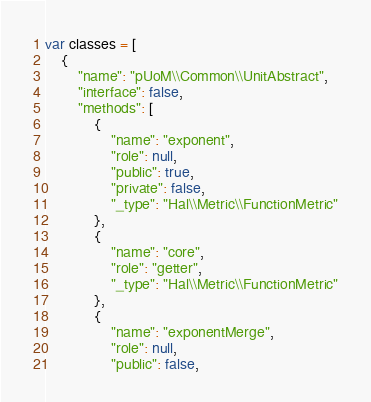<code> <loc_0><loc_0><loc_500><loc_500><_JavaScript_>var classes = [
    {
        "name": "pUoM\\Common\\UnitAbstract",
        "interface": false,
        "methods": [
            {
                "name": "exponent",
                "role": null,
                "public": true,
                "private": false,
                "_type": "Hal\\Metric\\FunctionMetric"
            },
            {
                "name": "core",
                "role": "getter",
                "_type": "Hal\\Metric\\FunctionMetric"
            },
            {
                "name": "exponentMerge",
                "role": null,
                "public": false,</code> 